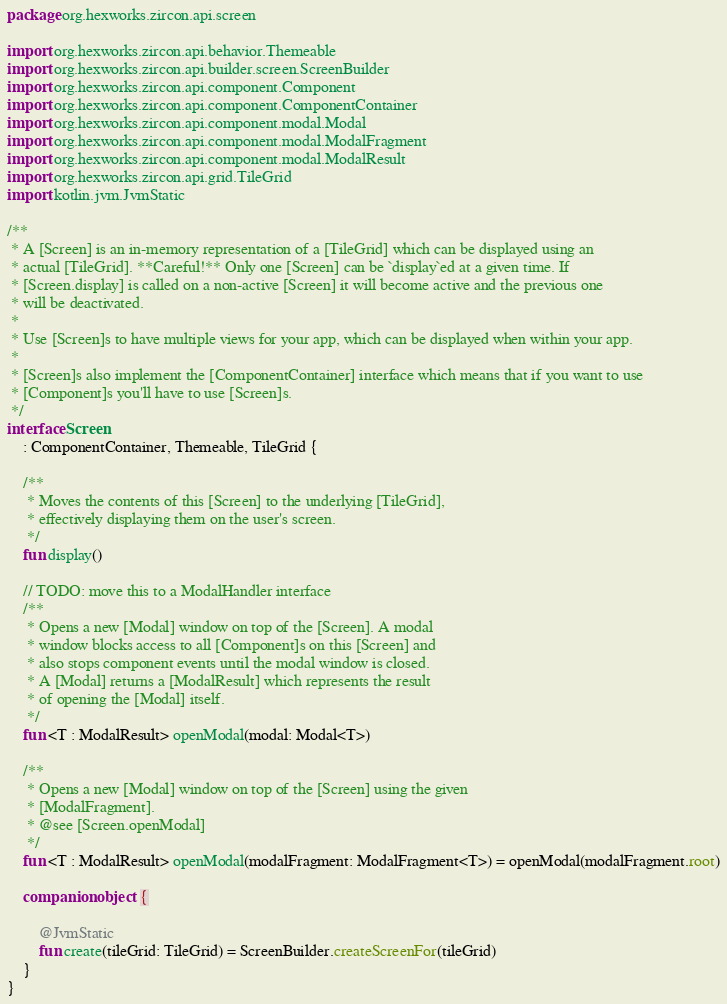<code> <loc_0><loc_0><loc_500><loc_500><_Kotlin_>package org.hexworks.zircon.api.screen

import org.hexworks.zircon.api.behavior.Themeable
import org.hexworks.zircon.api.builder.screen.ScreenBuilder
import org.hexworks.zircon.api.component.Component
import org.hexworks.zircon.api.component.ComponentContainer
import org.hexworks.zircon.api.component.modal.Modal
import org.hexworks.zircon.api.component.modal.ModalFragment
import org.hexworks.zircon.api.component.modal.ModalResult
import org.hexworks.zircon.api.grid.TileGrid
import kotlin.jvm.JvmStatic

/**
 * A [Screen] is an in-memory representation of a [TileGrid] which can be displayed using an
 * actual [TileGrid]. **Careful!** Only one [Screen] can be `display`ed at a given time. If
 * [Screen.display] is called on a non-active [Screen] it will become active and the previous one
 * will be deactivated.
 *
 * Use [Screen]s to have multiple views for your app, which can be displayed when within your app.
 *
 * [Screen]s also implement the [ComponentContainer] interface which means that if you want to use
 * [Component]s you'll have to use [Screen]s.
 */
interface Screen
    : ComponentContainer, Themeable, TileGrid {

    /**
     * Moves the contents of this [Screen] to the underlying [TileGrid],
     * effectively displaying them on the user's screen.
     */
    fun display()

    // TODO: move this to a ModalHandler interface
    /**
     * Opens a new [Modal] window on top of the [Screen]. A modal
     * window blocks access to all [Component]s on this [Screen] and
     * also stops component events until the modal window is closed.
     * A [Modal] returns a [ModalResult] which represents the result
     * of opening the [Modal] itself.
     */
    fun <T : ModalResult> openModal(modal: Modal<T>)

    /**
     * Opens a new [Modal] window on top of the [Screen] using the given
     * [ModalFragment].
     * @see [Screen.openModal]
     */
    fun <T : ModalResult> openModal(modalFragment: ModalFragment<T>) = openModal(modalFragment.root)

    companion object {

        @JvmStatic
        fun create(tileGrid: TileGrid) = ScreenBuilder.createScreenFor(tileGrid)
    }
}
</code> 